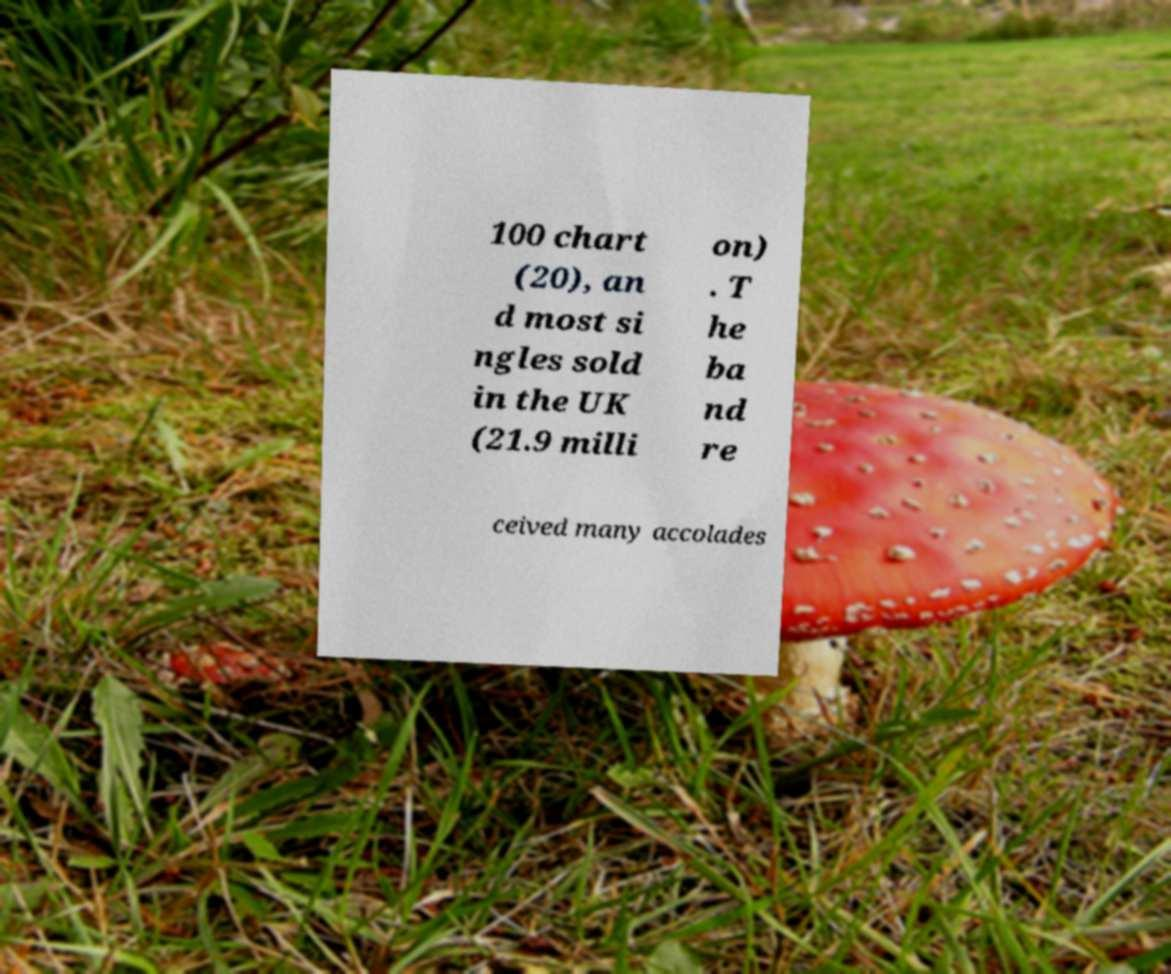Could you extract and type out the text from this image? 100 chart (20), an d most si ngles sold in the UK (21.9 milli on) . T he ba nd re ceived many accolades 